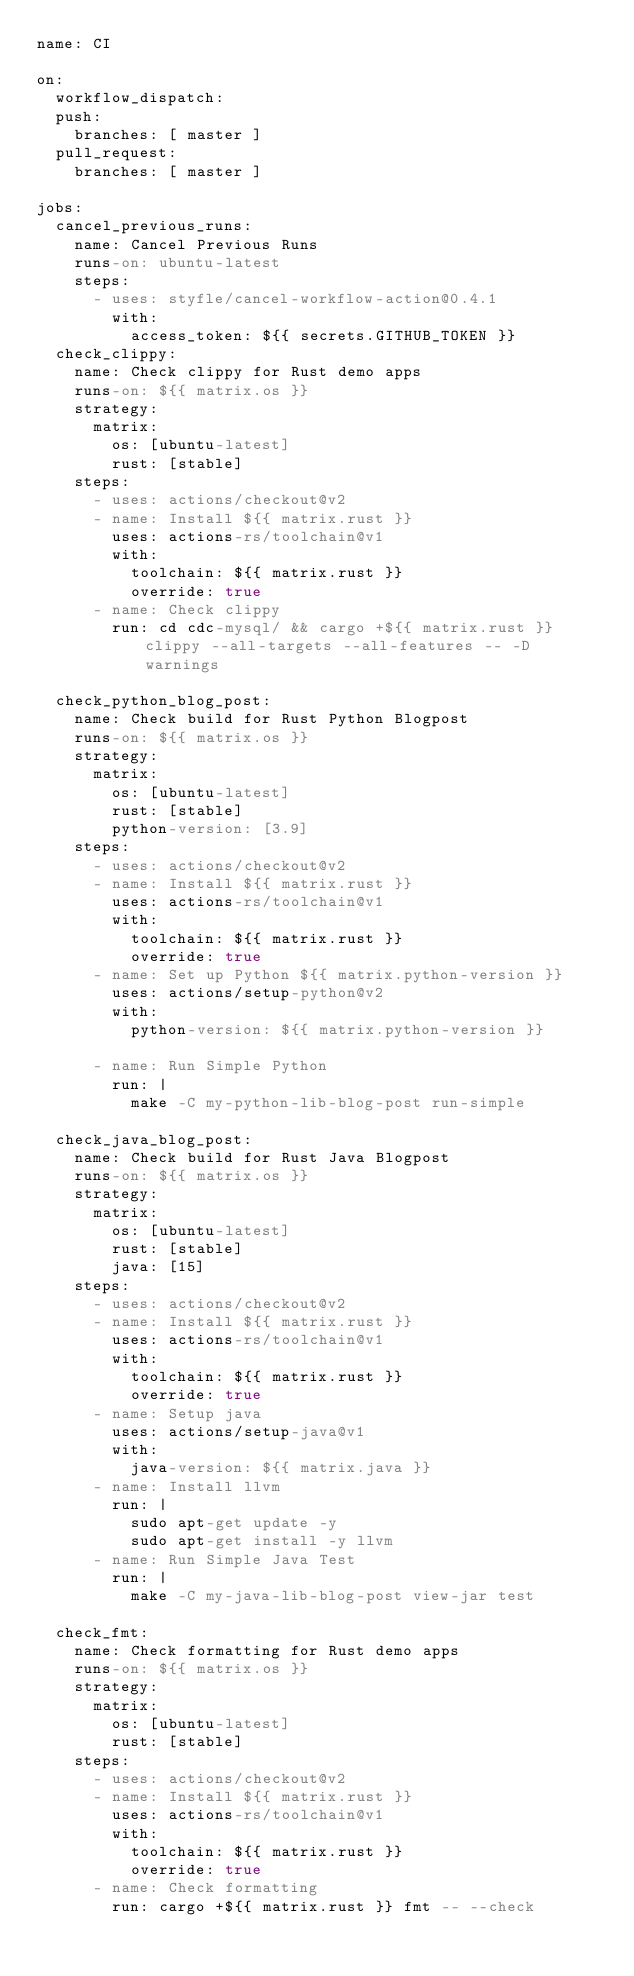<code> <loc_0><loc_0><loc_500><loc_500><_YAML_>name: CI

on:
  workflow_dispatch:
  push:
    branches: [ master ]
  pull_request:
    branches: [ master ]

jobs:
  cancel_previous_runs:
    name: Cancel Previous Runs
    runs-on: ubuntu-latest
    steps:
      - uses: styfle/cancel-workflow-action@0.4.1
        with:
          access_token: ${{ secrets.GITHUB_TOKEN }}
  check_clippy:
    name: Check clippy for Rust demo apps
    runs-on: ${{ matrix.os }}
    strategy:
      matrix:
        os: [ubuntu-latest]
        rust: [stable]
    steps:
      - uses: actions/checkout@v2
      - name: Install ${{ matrix.rust }}
        uses: actions-rs/toolchain@v1
        with:
          toolchain: ${{ matrix.rust }}
          override: true
      - name: Check clippy
        run: cd cdc-mysql/ && cargo +${{ matrix.rust }} clippy --all-targets --all-features -- -D warnings

  check_python_blog_post:
    name: Check build for Rust Python Blogpost
    runs-on: ${{ matrix.os }}
    strategy:
      matrix:
        os: [ubuntu-latest]
        rust: [stable]
        python-version: [3.9]
    steps:
      - uses: actions/checkout@v2
      - name: Install ${{ matrix.rust }}
        uses: actions-rs/toolchain@v1
        with:
          toolchain: ${{ matrix.rust }}
          override: true
      - name: Set up Python ${{ matrix.python-version }}
        uses: actions/setup-python@v2
        with:
          python-version: ${{ matrix.python-version }}

      - name: Run Simple Python
        run: |
          make -C my-python-lib-blog-post run-simple

  check_java_blog_post:
    name: Check build for Rust Java Blogpost
    runs-on: ${{ matrix.os }}
    strategy:
      matrix:
        os: [ubuntu-latest]
        rust: [stable]
        java: [15]
    steps:
      - uses: actions/checkout@v2
      - name: Install ${{ matrix.rust }}
        uses: actions-rs/toolchain@v1
        with:
          toolchain: ${{ matrix.rust }}
          override: true
      - name: Setup java
        uses: actions/setup-java@v1
        with:
          java-version: ${{ matrix.java }}
      - name: Install llvm
        run: |
          sudo apt-get update -y
          sudo apt-get install -y llvm
      - name: Run Simple Java Test
        run: |
          make -C my-java-lib-blog-post view-jar test

  check_fmt:
    name: Check formatting for Rust demo apps
    runs-on: ${{ matrix.os }}
    strategy:
      matrix:
        os: [ubuntu-latest]
        rust: [stable]
    steps:
      - uses: actions/checkout@v2
      - name: Install ${{ matrix.rust }}
        uses: actions-rs/toolchain@v1
        with:
          toolchain: ${{ matrix.rust }}
          override: true
      - name: Check formatting
        run: cargo +${{ matrix.rust }} fmt -- --check
</code> 